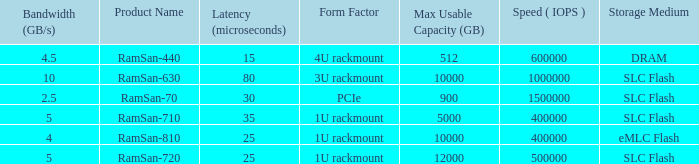List the number of ramsan-720 hard drives? 1.0. Would you be able to parse every entry in this table? {'header': ['Bandwidth (GB/s)', 'Product Name', 'Latency (microseconds)', 'Form Factor', 'Max Usable Capacity (GB)', 'Speed ( IOPS )', 'Storage Medium'], 'rows': [['4.5', 'RamSan-440', '15', '4U rackmount', '512', '600000', 'DRAM'], ['10', 'RamSan-630', '80', '3U rackmount', '10000', '1000000', 'SLC Flash'], ['2.5', 'RamSan-70', '30', 'PCIe', '900', '1500000', 'SLC Flash'], ['5', 'RamSan-710', '35', '1U rackmount', '5000', '400000', 'SLC Flash'], ['4', 'RamSan-810', '25', '1U rackmount', '10000', '400000', 'eMLC Flash'], ['5', 'RamSan-720', '25', '1U rackmount', '12000', '500000', 'SLC Flash']]} 